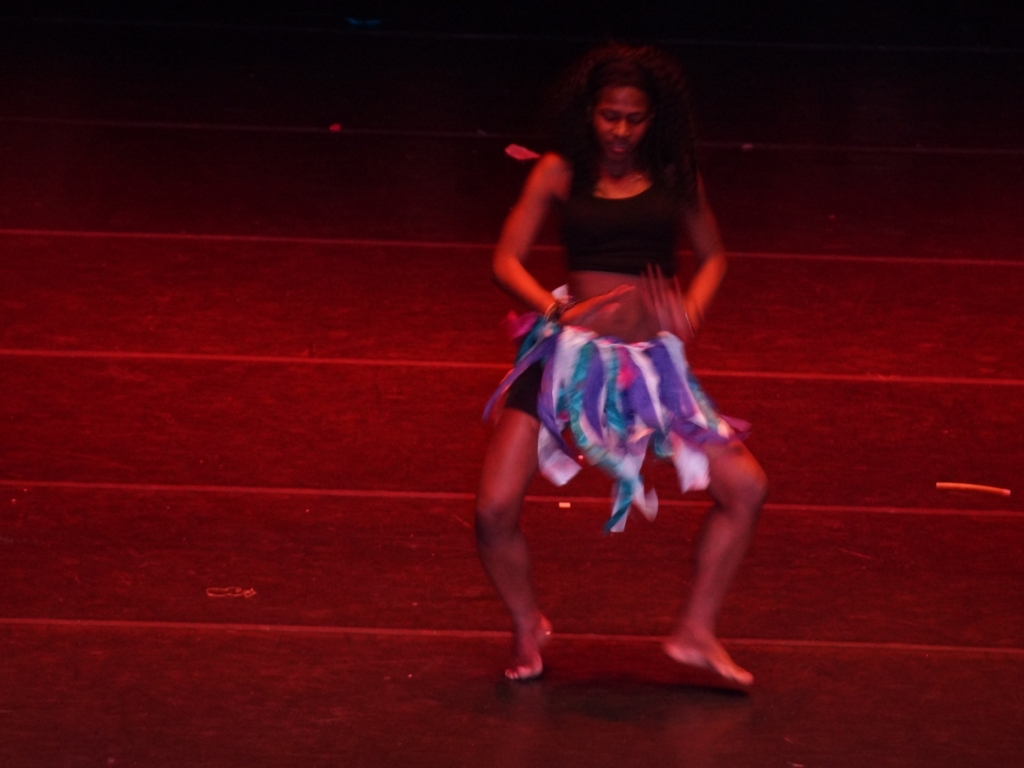What emotions does the dancer in the image seem to be expressing? The dancer's body language and movement exhibit a sense of freedom and joy. The fluidity of her skirt and the positioning of her arms suggest she's engaged in a dance that is both expressive and energetic. What type of dance could she be performing? While the specific dance style is not clear from the image alone, the dancer's attire and movement could suggest she's performing a type of contemporary or traditional African dance, known for its expressive nature and rhythmic movements. 